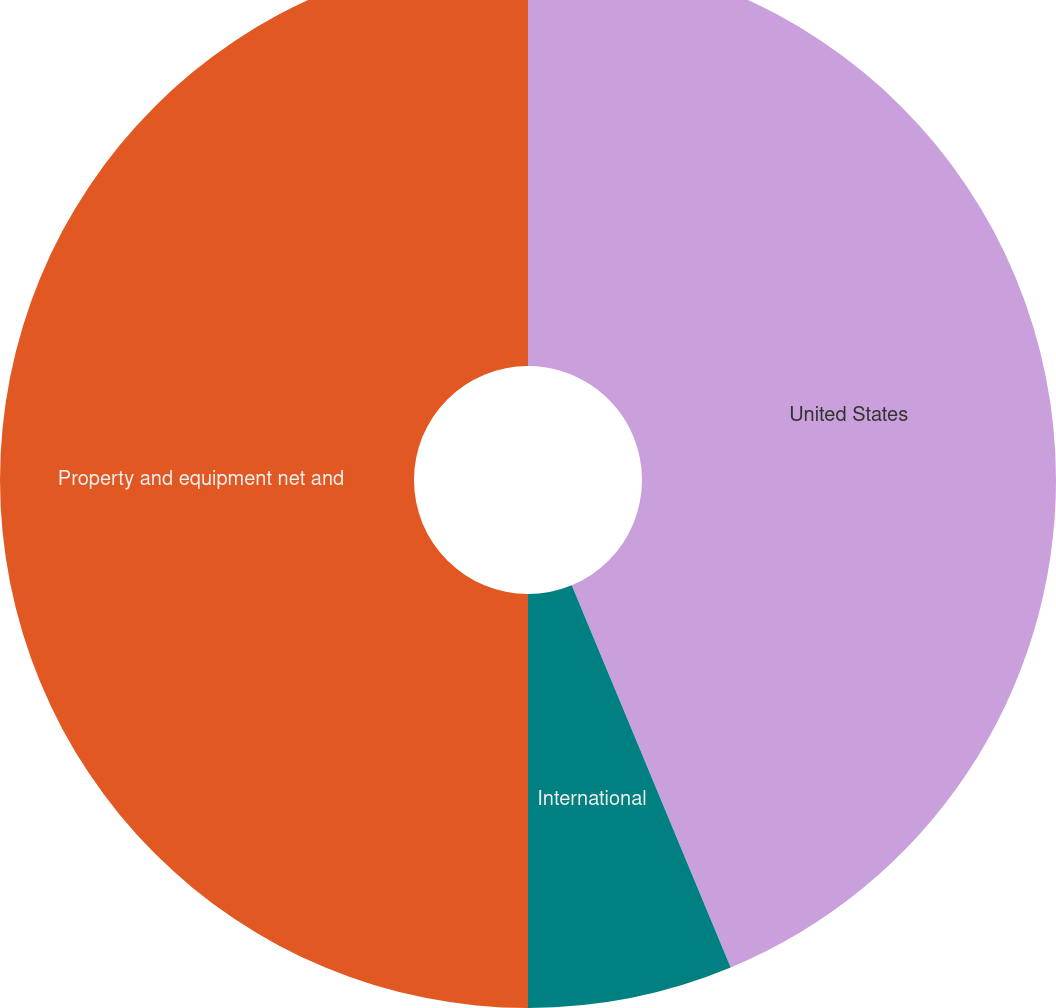Convert chart. <chart><loc_0><loc_0><loc_500><loc_500><pie_chart><fcel>United States<fcel>International<fcel>Property and equipment net and<nl><fcel>43.73%<fcel>6.27%<fcel>50.0%<nl></chart> 